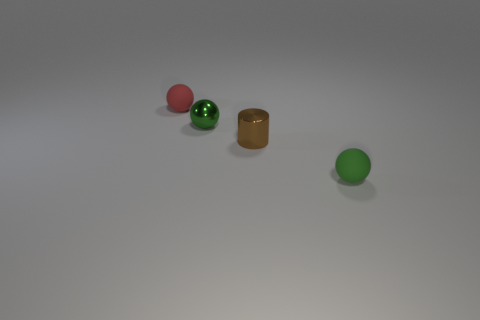Is the number of red rubber balls in front of the small metallic ball the same as the number of small cyan cylinders?
Your answer should be very brief. Yes. Does the green object in front of the tiny brown metallic object have the same shape as the small red matte object?
Provide a succinct answer. Yes. The small red matte thing is what shape?
Your answer should be compact. Sphere. What is the green thing that is left of the rubber ball that is on the right side of the small matte object that is on the left side of the brown metal object made of?
Your answer should be very brief. Metal. What material is the thing that is the same color as the metal ball?
Give a very brief answer. Rubber. How many things are either tiny shiny cylinders or green rubber balls?
Your answer should be very brief. 2. Are the green thing in front of the tiny green metal sphere and the tiny brown object made of the same material?
Give a very brief answer. No. What number of objects are either small matte spheres that are to the left of the green metal sphere or red matte objects?
Your answer should be very brief. 1. What color is the other tiny thing that is made of the same material as the red object?
Your answer should be very brief. Green. Are there any brown balls of the same size as the red thing?
Give a very brief answer. No. 